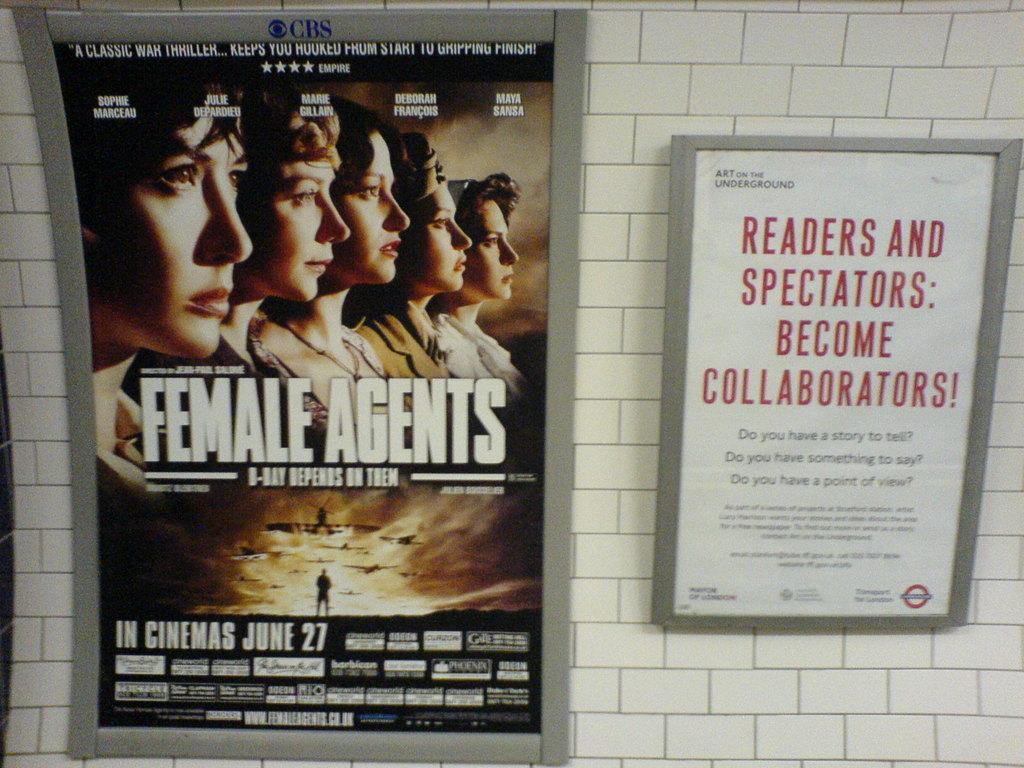Provide a one-sentence caption for the provided image. A movie poster for the movie Female Agents which opens June 27th. 